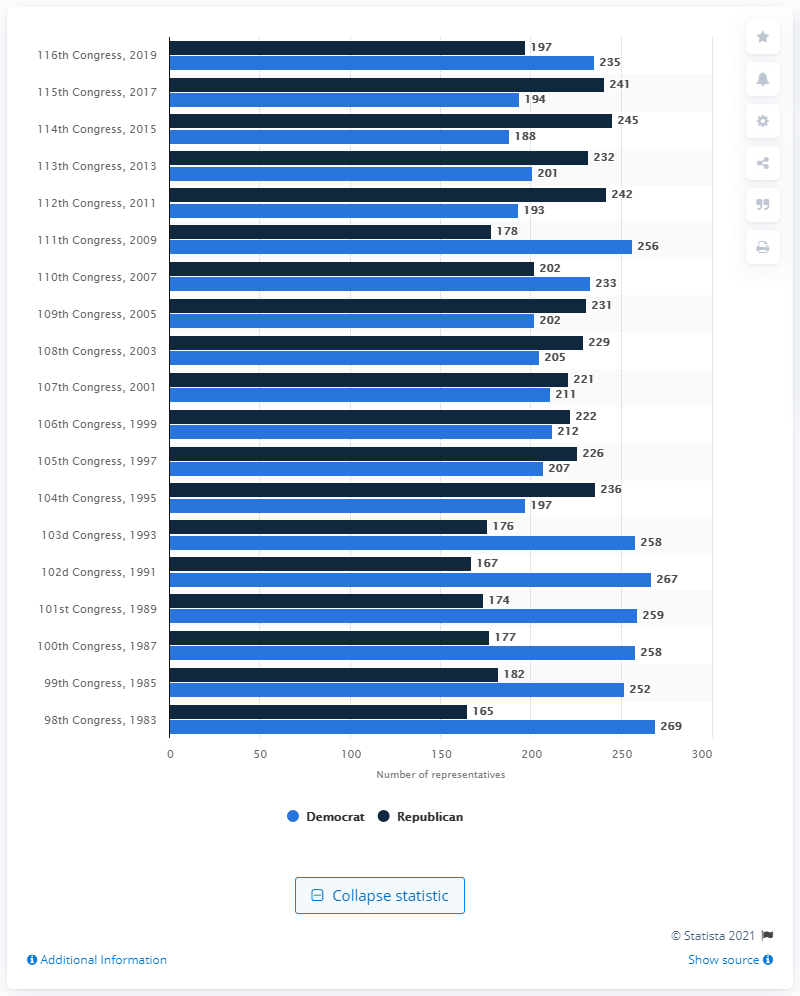Point out several critical features in this image. There are 197 Republican representatives in the 116th Congress. The 116th Congress is composed of 235 Democratic representatives. 